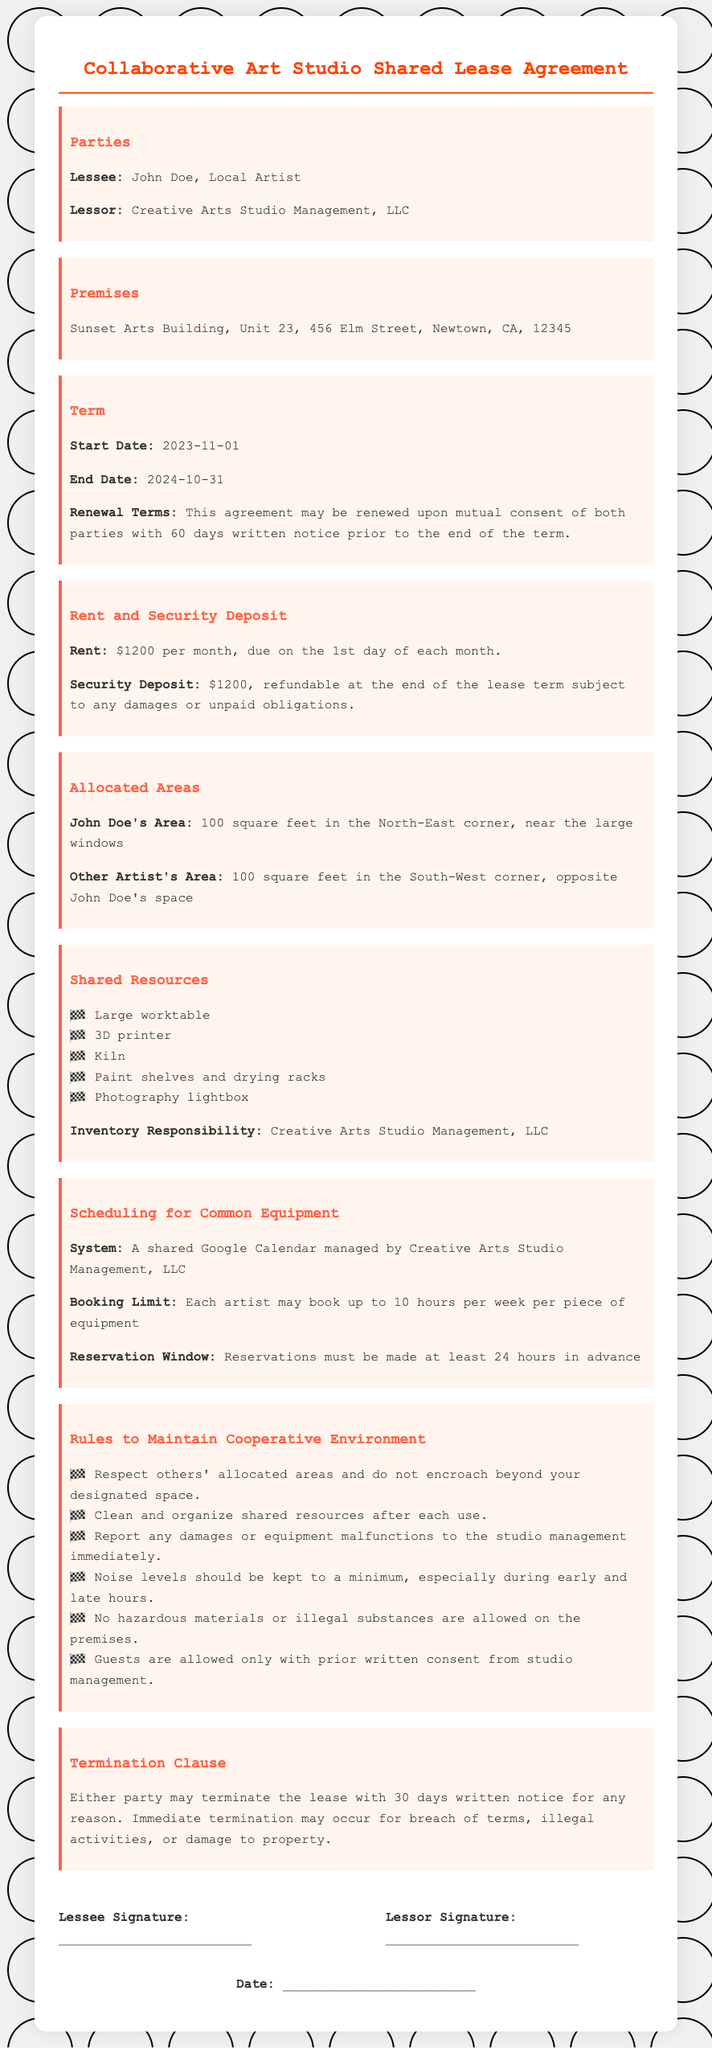what is the start date of the lease? The start date is specified under the "Term" section of the document.
Answer: 2023-11-01 what is the monthly rent? The monthly rent is stated in the "Rent and Security Deposit" section.
Answer: $1200 what is John Doe's allocated area size? The allocated area size for John Doe is mentioned in the "Allocated Areas" section.
Answer: 100 square feet how many hours per week can each artist book for equipment? The booking limit for each artist is found in the "Scheduling for Common Equipment" section.
Answer: 10 hours how long is the lease term? The lease term can be interpreted from the "Term" section considering the start and end dates.
Answer: 12 months what must be done if there are damages to equipment? The procedure for damages is outlined in the "Rules to Maintain Cooperative Environment" section.
Answer: Report to studio management what is the security deposit amount? The security deposit is specified in the "Rent and Security Deposit" section.
Answer: $1200 what kind of calendar is used for scheduling? The type of scheduling system is described in the "Scheduling for Common Equipment" section.
Answer: Google Calendar what notice is required for lease termination? The termination notice requirement is provided in the "Termination Clause" section.
Answer: 30 days 